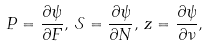<formula> <loc_0><loc_0><loc_500><loc_500>P = \frac { \partial \psi } { \partial F } , \, \mathcal { S } = \frac { \partial \psi } { \partial N } , \, z = \frac { \partial \psi } { \partial \nu } ,</formula> 